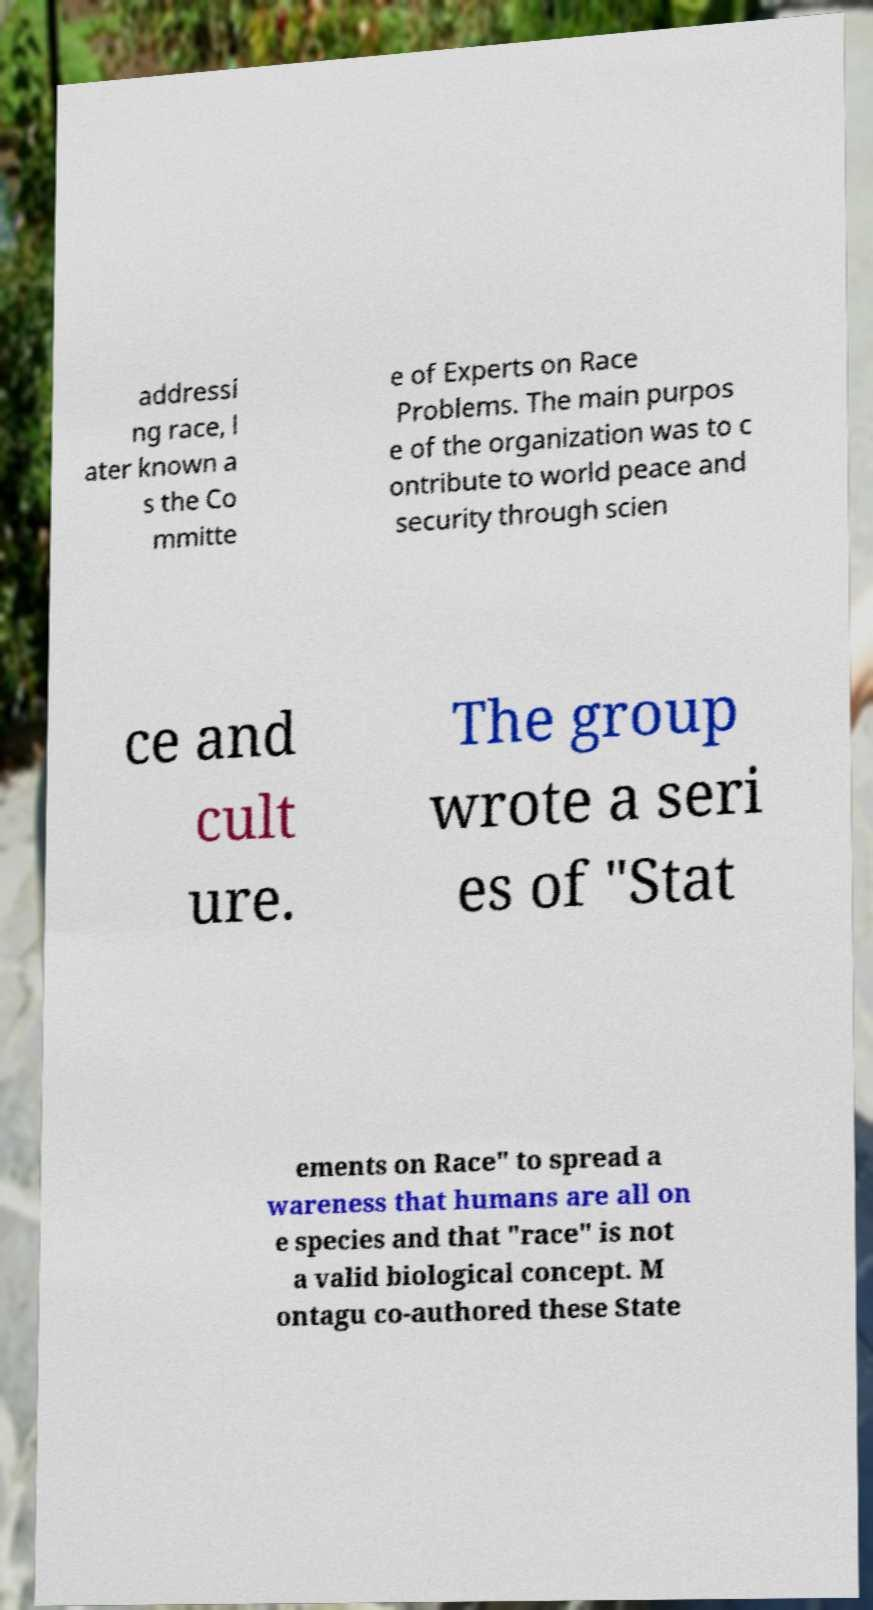Can you read and provide the text displayed in the image?This photo seems to have some interesting text. Can you extract and type it out for me? addressi ng race, l ater known a s the Co mmitte e of Experts on Race Problems. The main purpos e of the organization was to c ontribute to world peace and security through scien ce and cult ure. The group wrote a seri es of "Stat ements on Race" to spread a wareness that humans are all on e species and that "race" is not a valid biological concept. M ontagu co-authored these State 